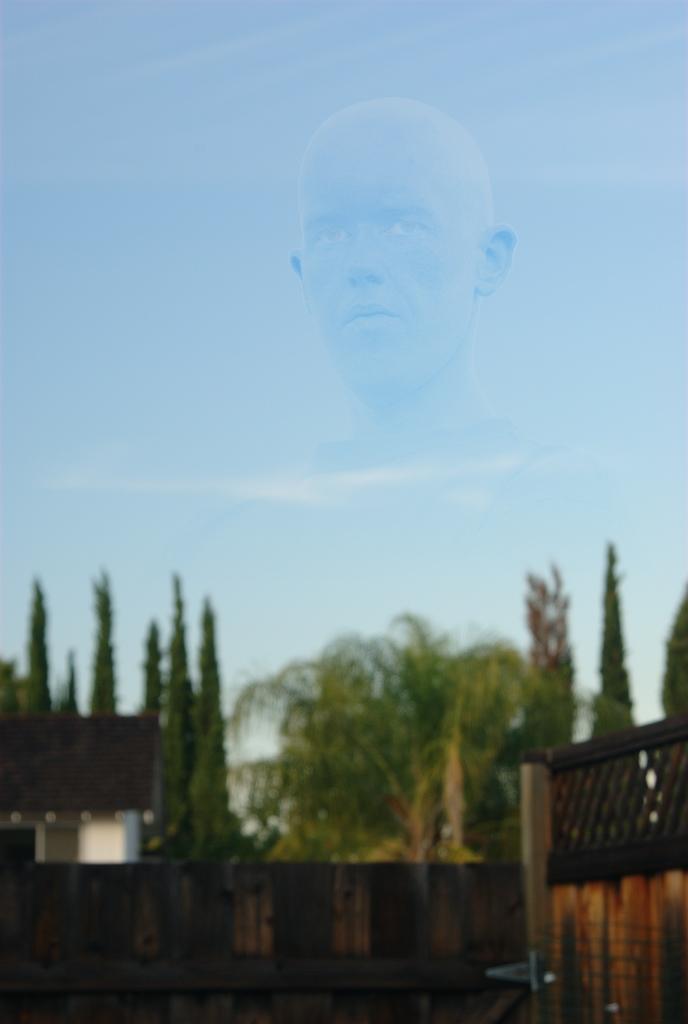Could you give a brief overview of what you see in this image? In this picture there are buildings and trees. At the top there is sky and there are clouds. At the top there is a picture of a person in the sky. 